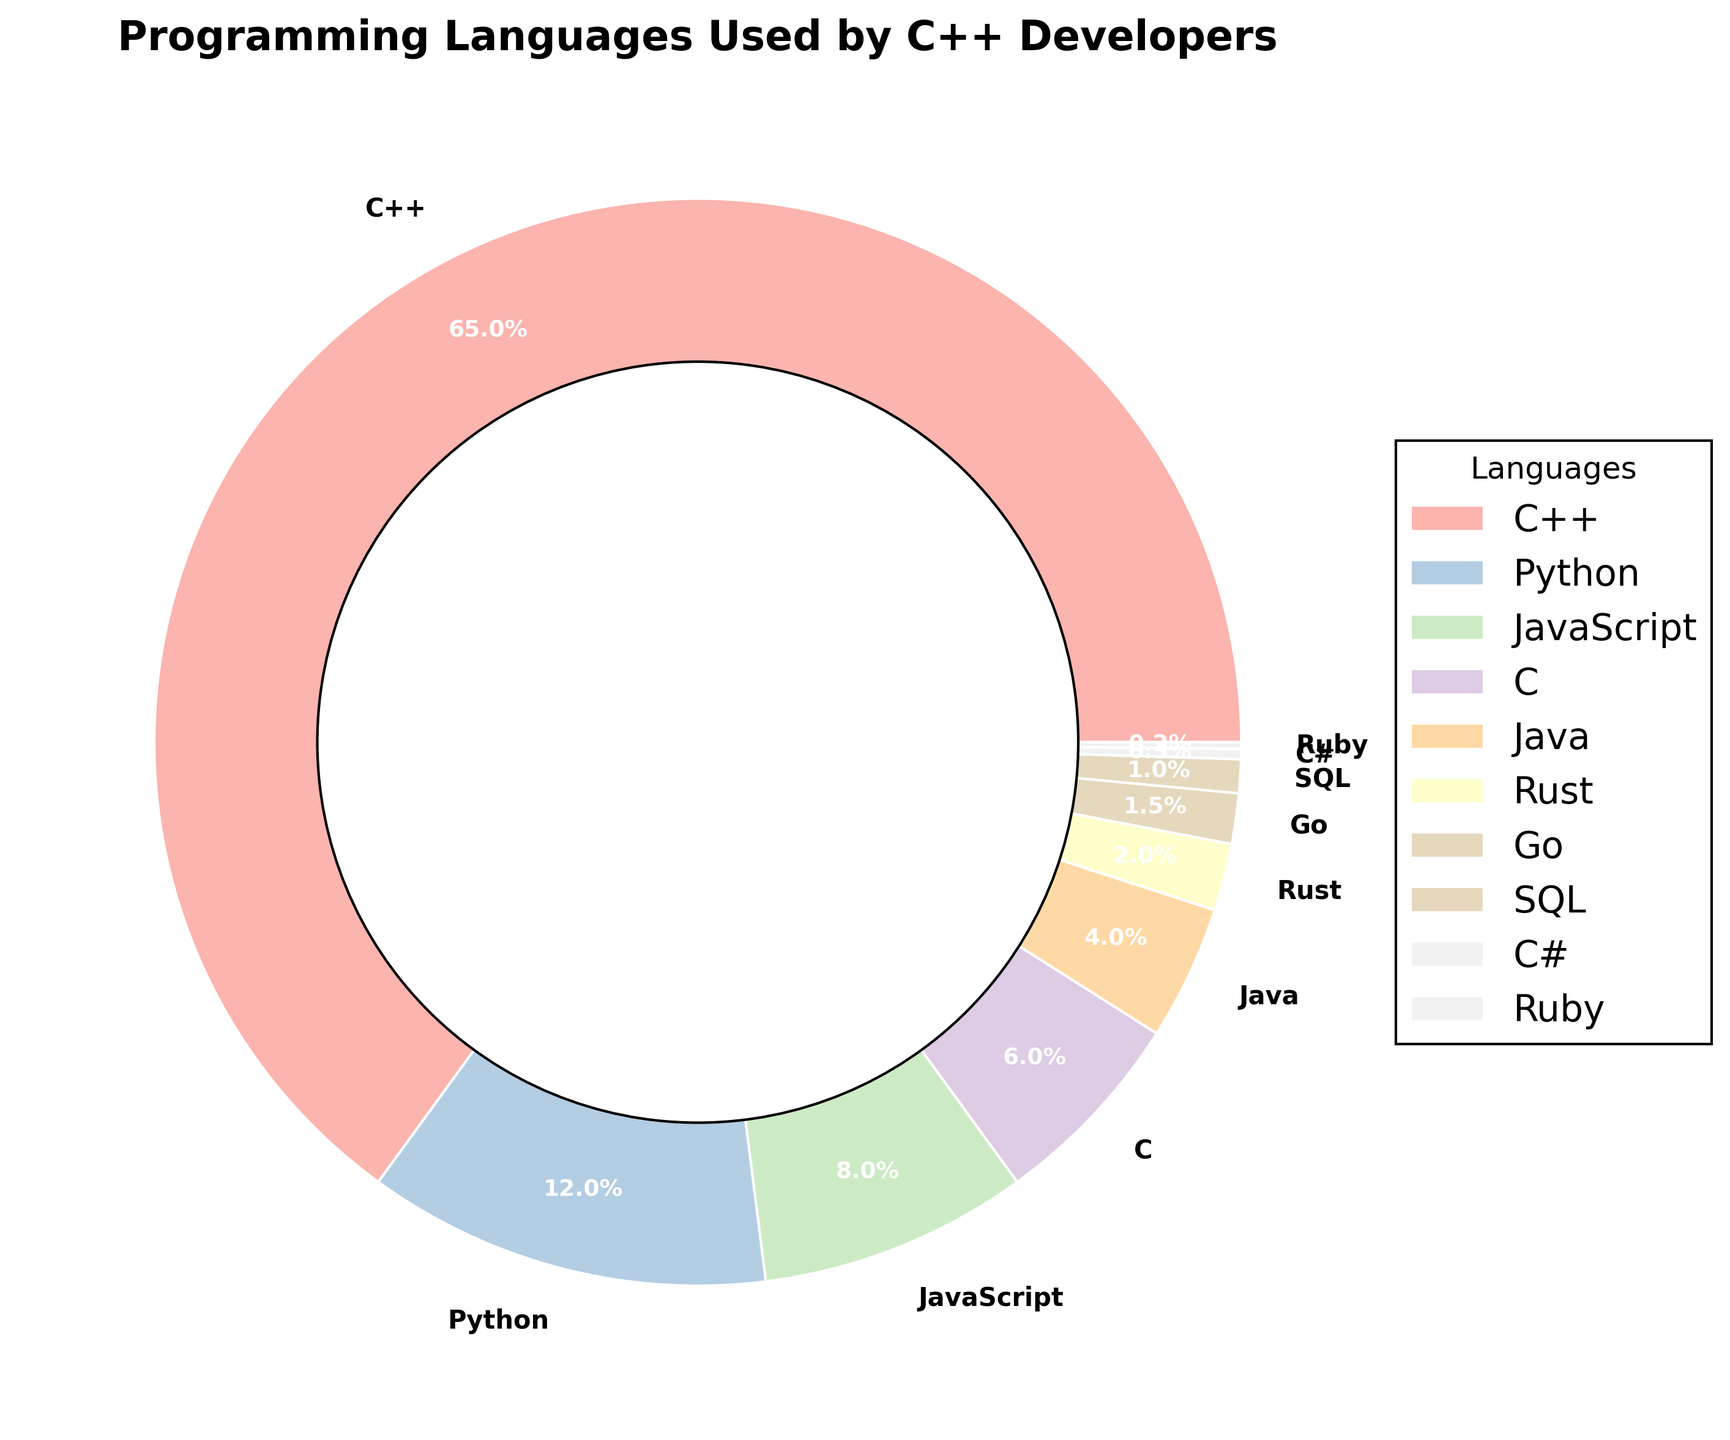How much more popular is Python than JavaScript among C++ developers? Python is 12% and JavaScript is 8%. Subtract the percentage of JavaScript from Python: 12 - 8 = 4.
Answer: 4% Which language is used the least by C++ developers? The wedge with the smallest percentage on the chart is Ruby, which has a percentage of 0.2%.
Answer: Ruby What is the total percentage of developers who use languages other than C++? Add up the percentages of all languages except C++: 12 + 8 + 6 + 4 + 2 + 1.5 + 1 + 0.3 + 0.2 = 35.
Answer: 35% How many times more popular is C++ compared to Rust among C++ developers? C++ is 65% and Rust is 2%. Divide the percentage of C++ by Rust: 65 ÷ 2 = 32.5.
Answer: 32.5 times Which two languages combined make up almost the same percentage as C++ alone? The percentages of Python and JavaScript combined are 12 + 8 = 20, which is much less than 65. The percentages of C and Java combined are 6 + 4 = 10, which is much less than 65. The combination of Python and other languages still do not add up to nearly 65%. Therefore, none of the two languages combined match the percentage of C++.
Answer: None What is the difference in percentage between the most and the least popular languages? The most popular language is C++, which is 65%, and the least popular is Ruby at 0.2%. Subtract Ruby's percentage from C++: 65 - 0.2 = 64.8.
Answer: 64.8% Which languages have a percentage of use less than 5%? From the chart, Java at 4%, Rust at 2%, Go at 1.5%, SQL at 1%, C# at 0.3%, and Ruby at 0.2% are all less than 5%.
Answer: Java, Rust, Go, SQL, C#, Ruby Is the combined usage of Go and SQL more than or less than the usage of Rust? Go is 1.5% and SQL is 1%. Their combined usage is 1.5 + 1 = 2.5%, which is more than Rust at 2%.
Answer: More What is the average percentage usage of Python, JavaScript, and C among the C++ developers? Sum the percentages of Python, JavaScript, and C: 12 + 8 + 6 = 26. Divide by the number of languages (3): 26 ÷ 3 ≈ 8.67.
Answer: 8.67% How do the percentages of Go and SQL compare visually on the chart? The wedges for Go and SQL appear to be narrow, with Go slightly larger than SQL based on the percentage data of 1.5% for Go and 1% for SQL.
Answer: Go is slightly larger 